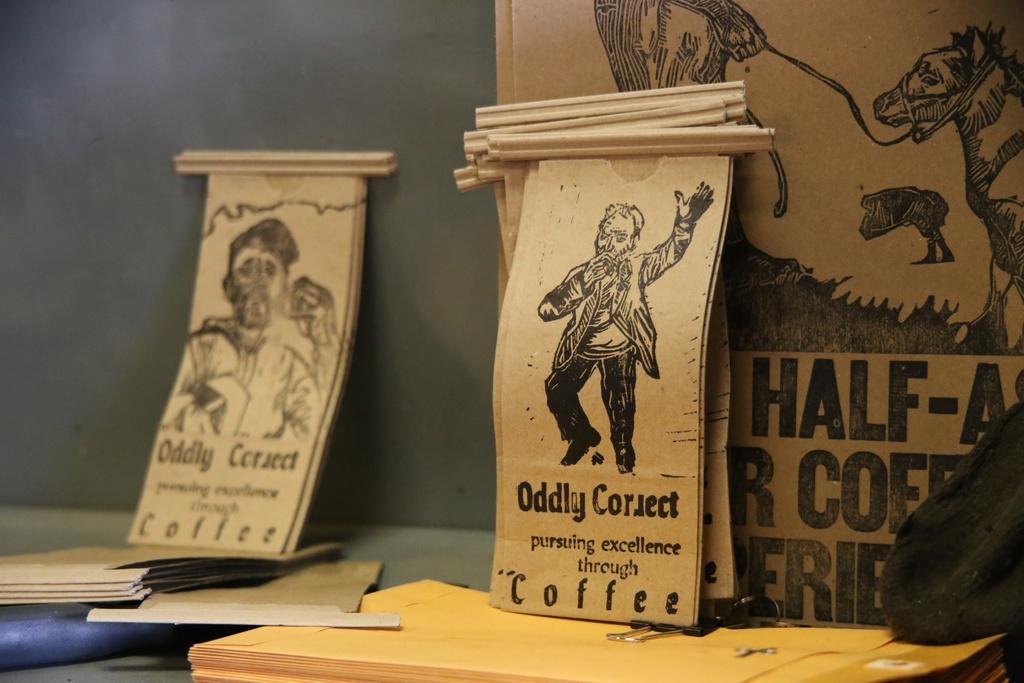What is the name on the poster?
Provide a short and direct response. Oddly correct. 